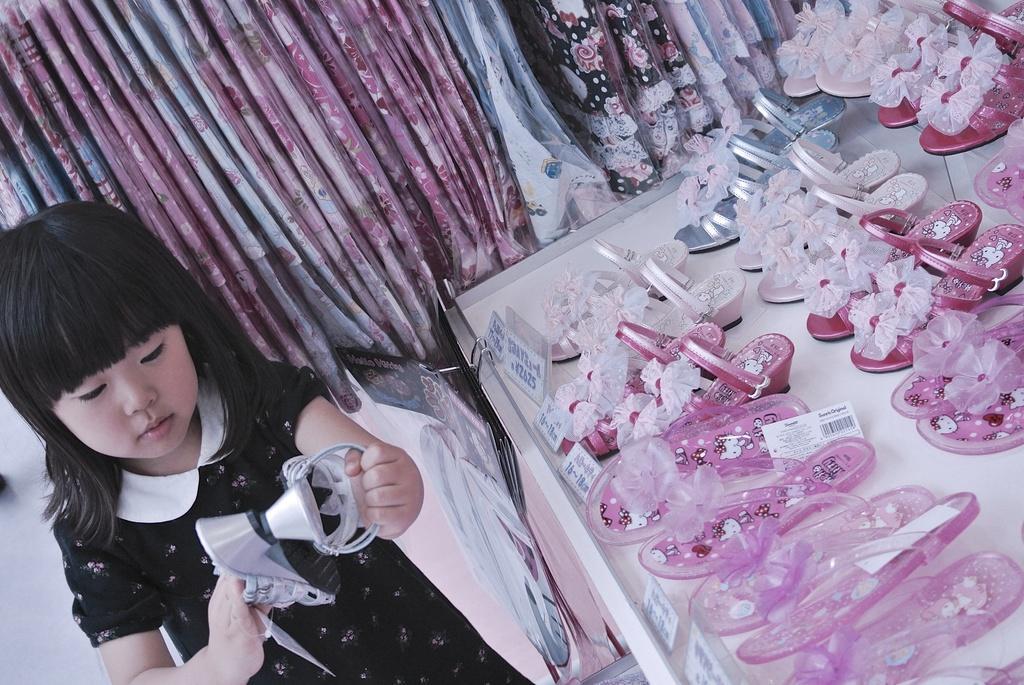Can you describe this image briefly? In this image there is a girl in the middle who is playing with the slippers. Beside her there is a table on which there are so many pairs of footwear. In the background there is a curtain. 